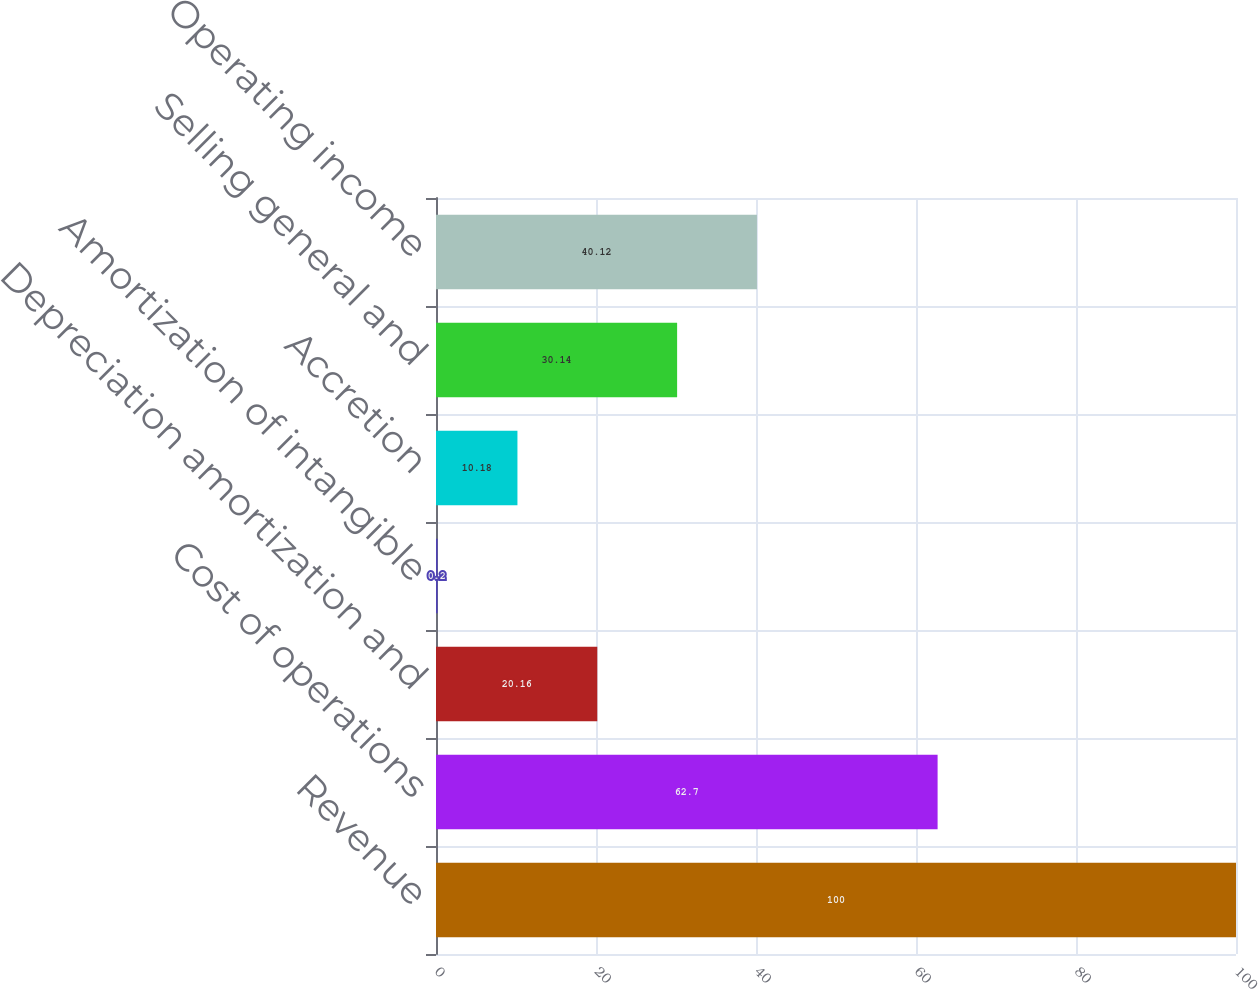Convert chart. <chart><loc_0><loc_0><loc_500><loc_500><bar_chart><fcel>Revenue<fcel>Cost of operations<fcel>Depreciation amortization and<fcel>Amortization of intangible<fcel>Accretion<fcel>Selling general and<fcel>Operating income<nl><fcel>100<fcel>62.7<fcel>20.16<fcel>0.2<fcel>10.18<fcel>30.14<fcel>40.12<nl></chart> 